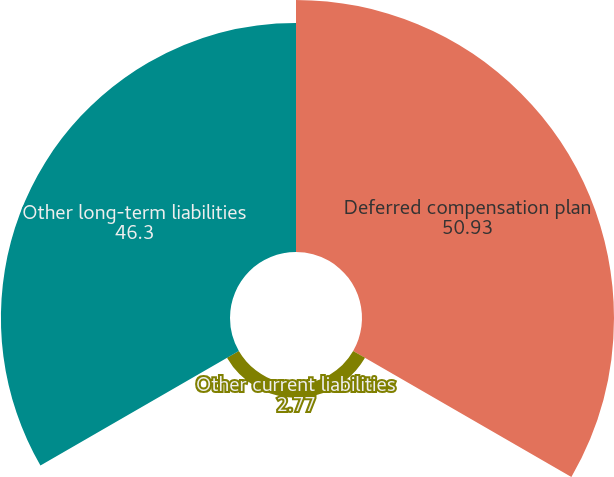Convert chart. <chart><loc_0><loc_0><loc_500><loc_500><pie_chart><fcel>Deferred compensation plan<fcel>Other current liabilities<fcel>Other long-term liabilities<nl><fcel>50.93%<fcel>2.77%<fcel>46.3%<nl></chart> 